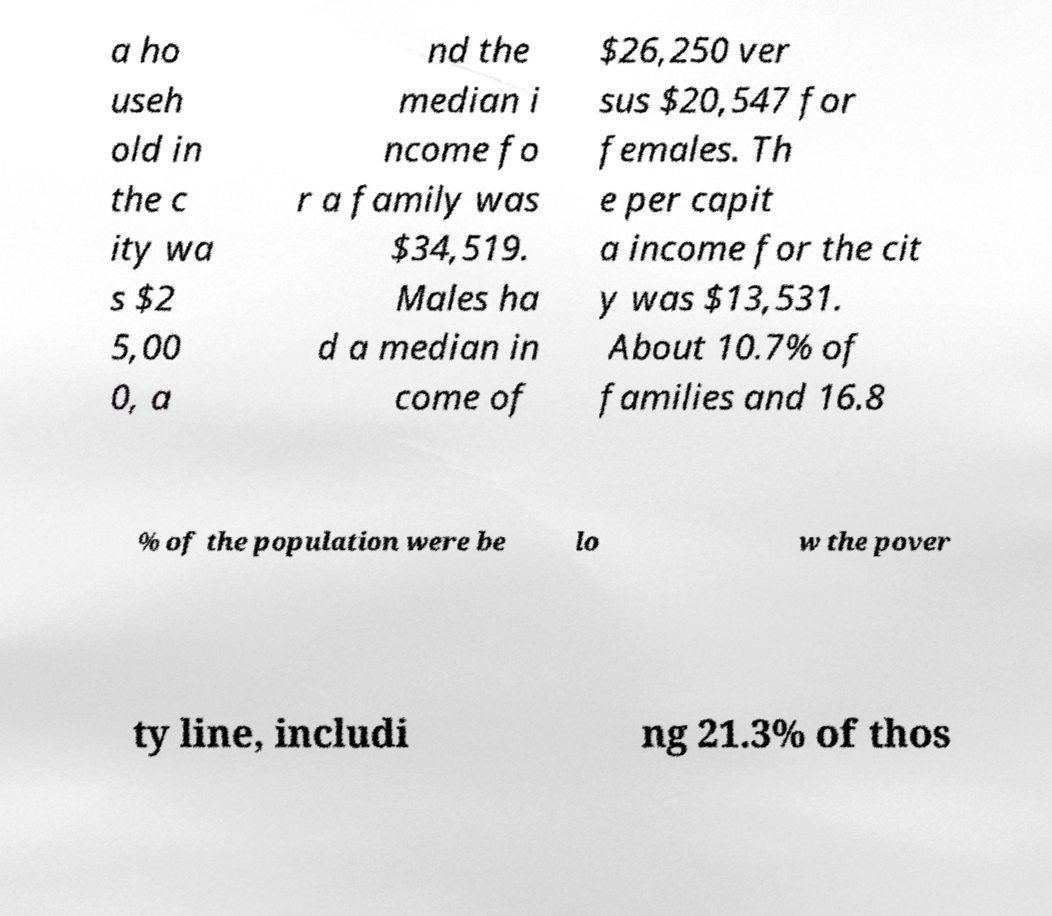Could you extract and type out the text from this image? a ho useh old in the c ity wa s $2 5,00 0, a nd the median i ncome fo r a family was $34,519. Males ha d a median in come of $26,250 ver sus $20,547 for females. Th e per capit a income for the cit y was $13,531. About 10.7% of families and 16.8 % of the population were be lo w the pover ty line, includi ng 21.3% of thos 